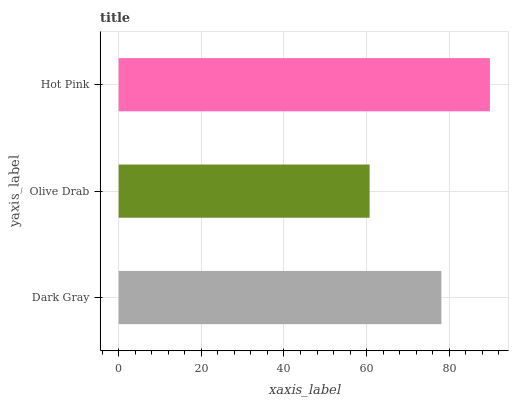Is Olive Drab the minimum?
Answer yes or no. Yes. Is Hot Pink the maximum?
Answer yes or no. Yes. Is Hot Pink the minimum?
Answer yes or no. No. Is Olive Drab the maximum?
Answer yes or no. No. Is Hot Pink greater than Olive Drab?
Answer yes or no. Yes. Is Olive Drab less than Hot Pink?
Answer yes or no. Yes. Is Olive Drab greater than Hot Pink?
Answer yes or no. No. Is Hot Pink less than Olive Drab?
Answer yes or no. No. Is Dark Gray the high median?
Answer yes or no. Yes. Is Dark Gray the low median?
Answer yes or no. Yes. Is Hot Pink the high median?
Answer yes or no. No. Is Olive Drab the low median?
Answer yes or no. No. 